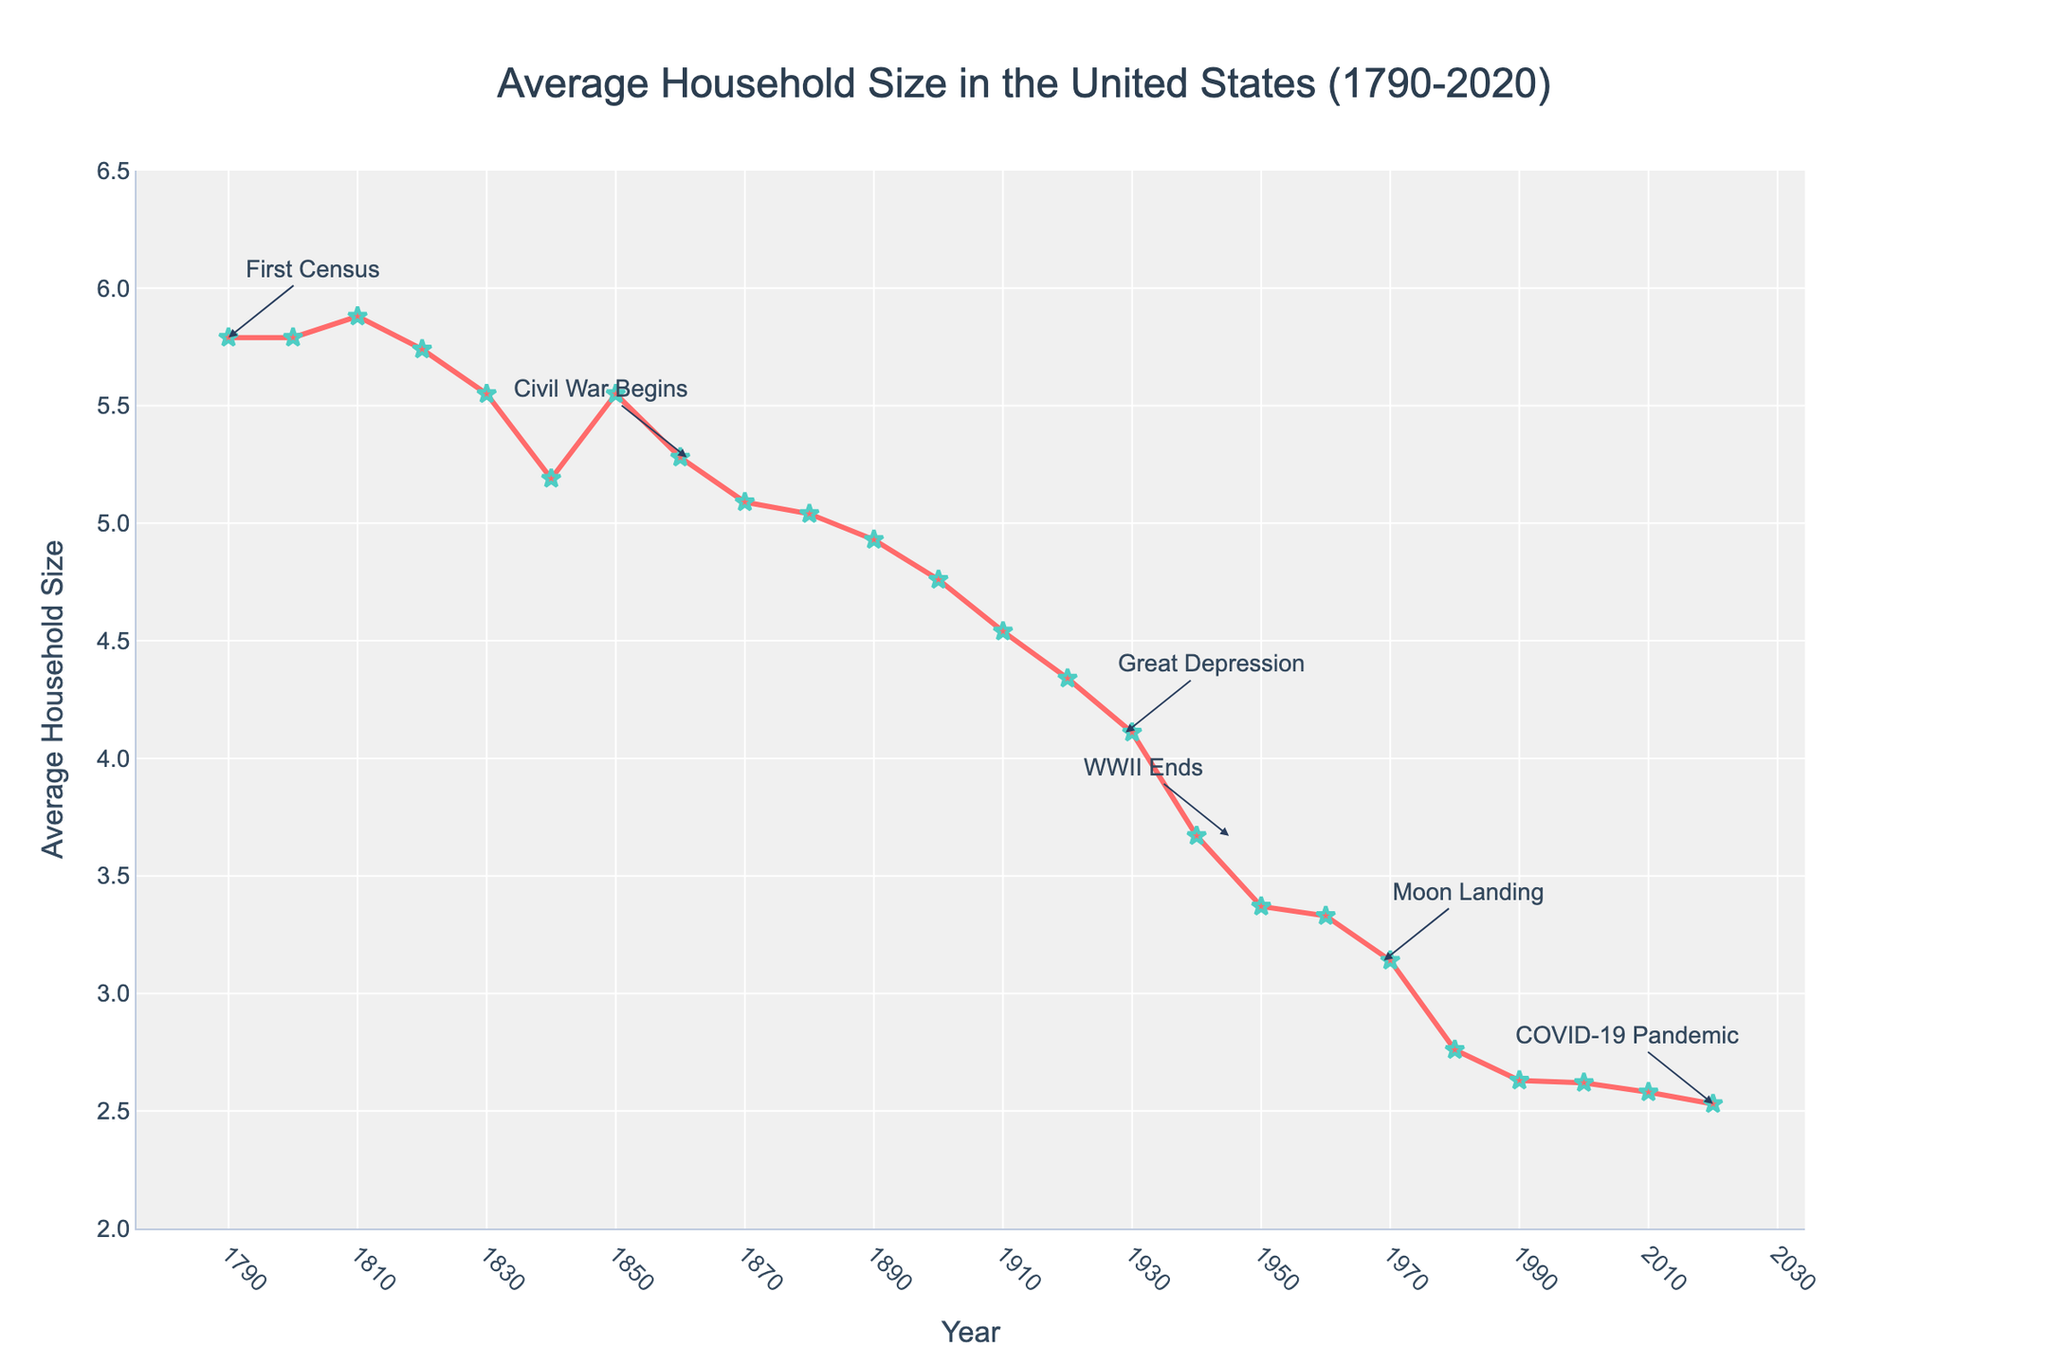What is the Average Household Size in the United States in 2020? To find the Average Household Size in 2020, we need to refer to the figure and look for the value corresponding to the year 2020. The annotation for 2020 reads "2.53".
Answer: 2.53 How did the Average Household Size change from 1790 to 2020? To understand the change, compare the values for 1790 and 2020. In 1790, the size was 5.79, and in 2020, it was 2.53. The change is a decrease of 5.79 - 2.53 = 3.26.
Answer: Decreased by 3.26 During which historical event did the Average Household Size decrease from 4.11 to 3.67? Check the annotations for historical events and match the years to the Average Household Size values. The value 4.11 corresponds to the Great Depression (1929), and 3.67 corresponds to WWII ends (1945).
Answer: WWII ends What was the Average Household Size during the peak of the Great Depression? According to the annotations, the Great Depression peaked around 1929. Search for the Average Household Size corresponding to 1929, which is 4.11.
Answer: 4.11 Compare the Average Household Size during the Civil War with the Average Household Size in 2010. Which was larger, and by how much? The Civil War began in 1861, and the Average Household Size was 5.28. In 2010, it was 2.58. To find which is larger and by how much, subtract the smaller from the larger: 5.28 - 2.58 = 2.70.
Answer: Civil War, by 2.70 What is the trend of the Average Household Size from 1950 to 1980? To identify the trend, observe the values from 1950 to 1980: in 1950 (3.37), 1960 (3.33), 1970 (3.14), and 1980 (2.76). The size shows a continuous decrease over these years.
Answer: Decreasing In which decade did the Average Household Size first drop below 4? Look for the year where the Average Household Size dropped below 4 for the first time. The value drops below 4 at the beginning of the 1940s (3.67).
Answer: 1940s Which historical event is closest to the time the Average Household Size was 4.54? Check the annotations for historical events and match them to the closest year. The value 4.54 corresponds to 1910, and the closest event is the Great Depression (1929).
Answer: Great Depression What is the difference in Average Household Size between the end of WWII and the COVID-19 pandemic? Refer to the annotations: WWII ends (1945) had a value of 3.67, and the COVID-19 pandemic (2020) had 2.53. The difference is 3.67 - 2.53 = 1.14.
Answer: 1.14 How does the Average Household Size in 1890 compare to that in 2000? In 1890, the Average Household Size was 4.93. In 2000, it was 2.62. Comparing the two, 4.93 is greater than 2.62 by a difference of 4.93 - 2.62 = 2.31.
Answer: 1890 is larger by 2.31 